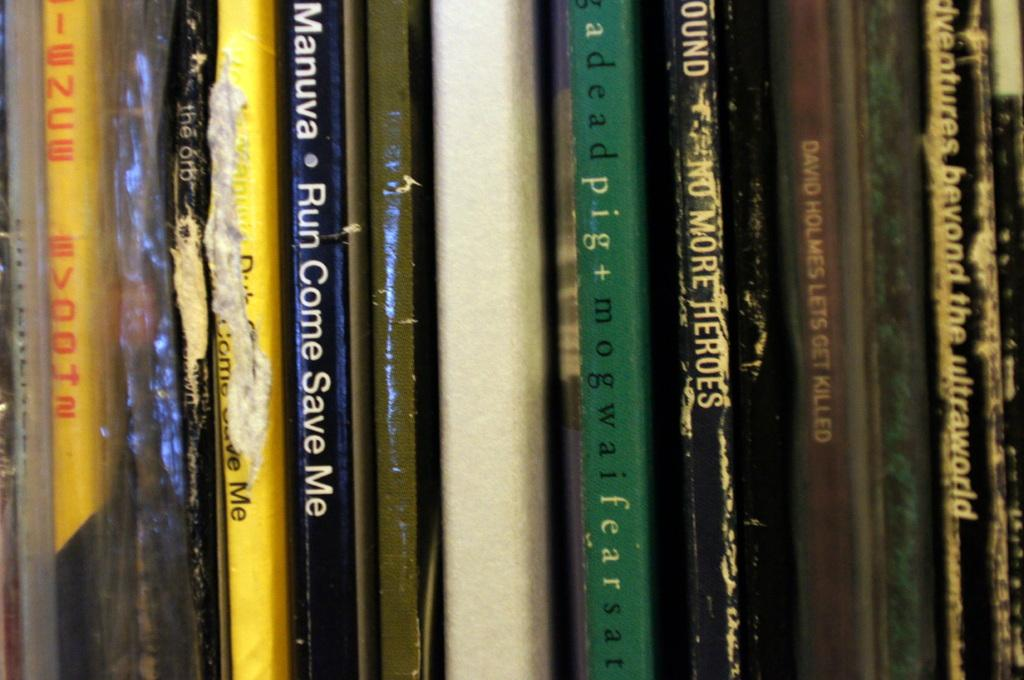<image>
Relay a brief, clear account of the picture shown. A book titled Run Come Save me that is blue and white. 